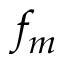<formula> <loc_0><loc_0><loc_500><loc_500>f _ { m }</formula> 